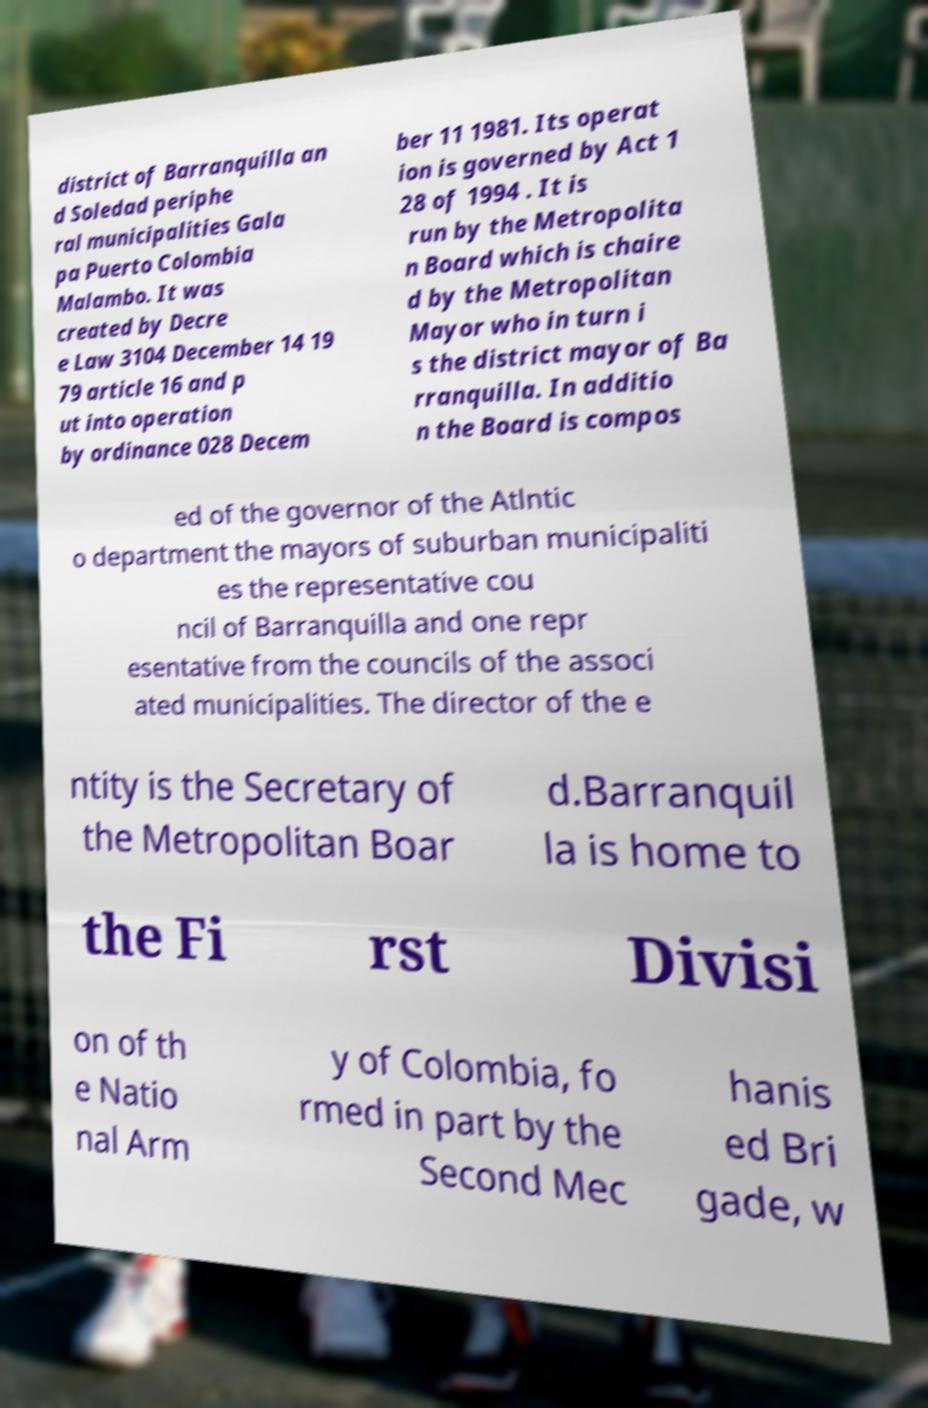There's text embedded in this image that I need extracted. Can you transcribe it verbatim? district of Barranquilla an d Soledad periphe ral municipalities Gala pa Puerto Colombia Malambo. It was created by Decre e Law 3104 December 14 19 79 article 16 and p ut into operation by ordinance 028 Decem ber 11 1981. Its operat ion is governed by Act 1 28 of 1994 . It is run by the Metropolita n Board which is chaire d by the Metropolitan Mayor who in turn i s the district mayor of Ba rranquilla. In additio n the Board is compos ed of the governor of the Atlntic o department the mayors of suburban municipaliti es the representative cou ncil of Barranquilla and one repr esentative from the councils of the associ ated municipalities. The director of the e ntity is the Secretary of the Metropolitan Boar d.Barranquil la is home to the Fi rst Divisi on of th e Natio nal Arm y of Colombia, fo rmed in part by the Second Mec hanis ed Bri gade, w 